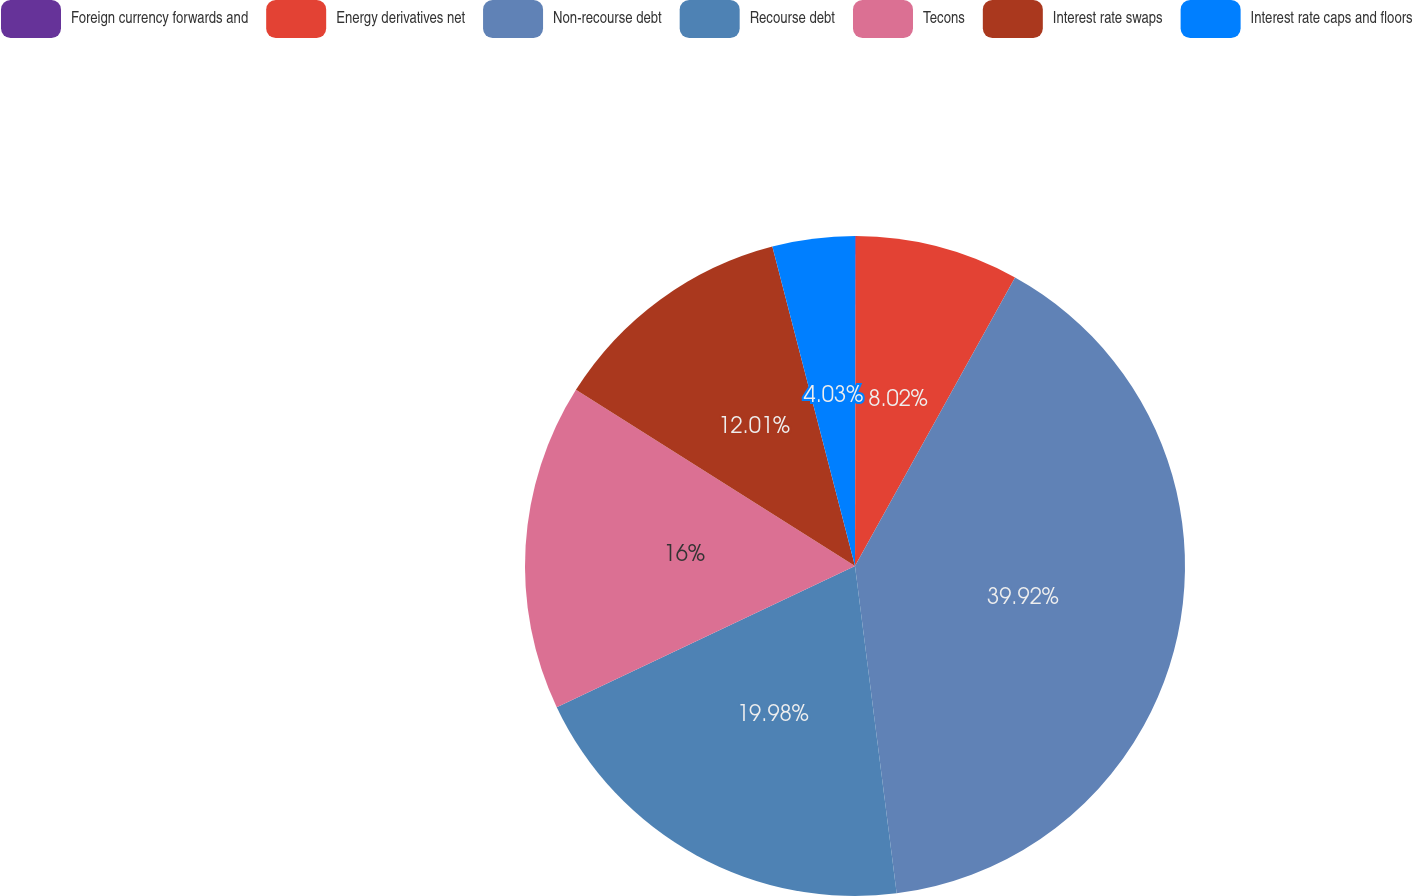Convert chart to OTSL. <chart><loc_0><loc_0><loc_500><loc_500><pie_chart><fcel>Foreign currency forwards and<fcel>Energy derivatives net<fcel>Non-recourse debt<fcel>Recourse debt<fcel>Tecons<fcel>Interest rate swaps<fcel>Interest rate caps and floors<nl><fcel>0.04%<fcel>8.02%<fcel>39.93%<fcel>19.98%<fcel>16.0%<fcel>12.01%<fcel>4.03%<nl></chart> 